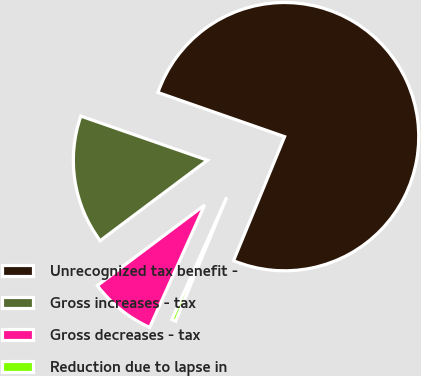<chart> <loc_0><loc_0><loc_500><loc_500><pie_chart><fcel>Unrecognized tax benefit -<fcel>Gross increases - tax<fcel>Gross decreases - tax<fcel>Reduction due to lapse in<nl><fcel>75.88%<fcel>15.58%<fcel>8.04%<fcel>0.5%<nl></chart> 